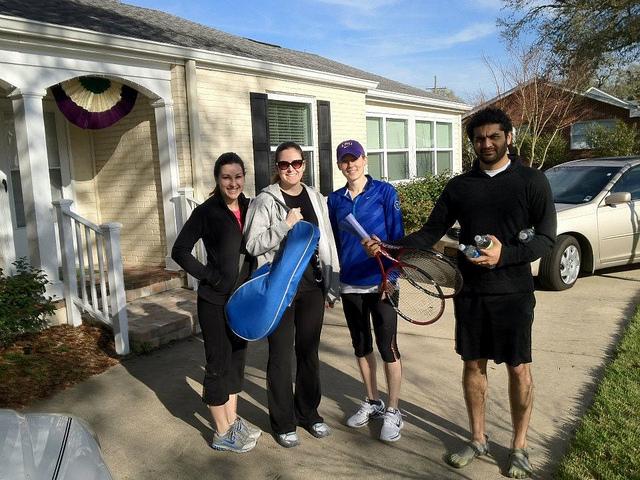What sport are they prepared to play?
Concise answer only. Tennis. What is the man holding?
Be succinct. Tennis racket. Can they use the driveway to play their sport?
Write a very short answer. No. 